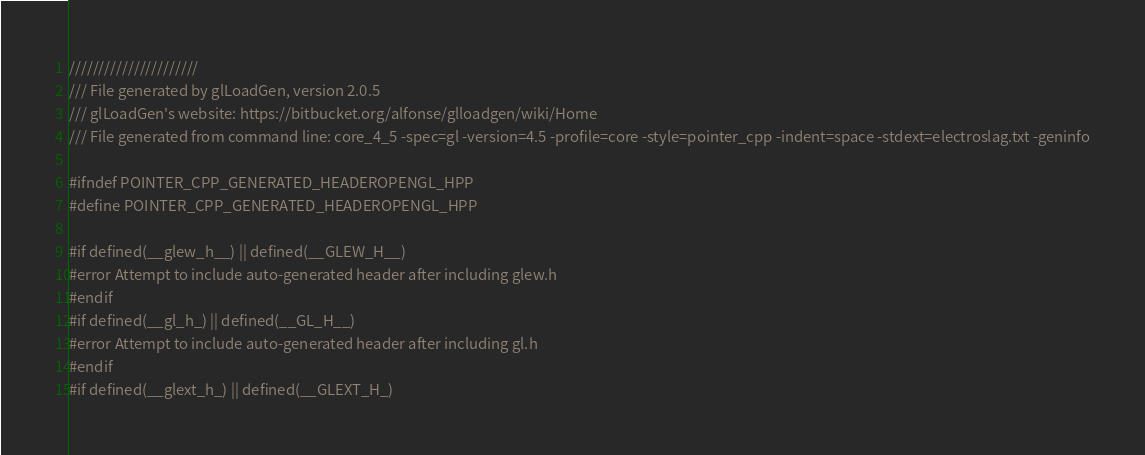<code> <loc_0><loc_0><loc_500><loc_500><_C++_>//////////////////////
/// File generated by glLoadGen, version 2.0.5
/// glLoadGen's website: https://bitbucket.org/alfonse/glloadgen/wiki/Home
/// File generated from command line: core_4_5 -spec=gl -version=4.5 -profile=core -style=pointer_cpp -indent=space -stdext=electroslag.txt -geninfo

#ifndef POINTER_CPP_GENERATED_HEADEROPENGL_HPP
#define POINTER_CPP_GENERATED_HEADEROPENGL_HPP

#if defined(__glew_h__) || defined(__GLEW_H__)
#error Attempt to include auto-generated header after including glew.h
#endif
#if defined(__gl_h_) || defined(__GL_H__)
#error Attempt to include auto-generated header after including gl.h
#endif
#if defined(__glext_h_) || defined(__GLEXT_H_)</code> 